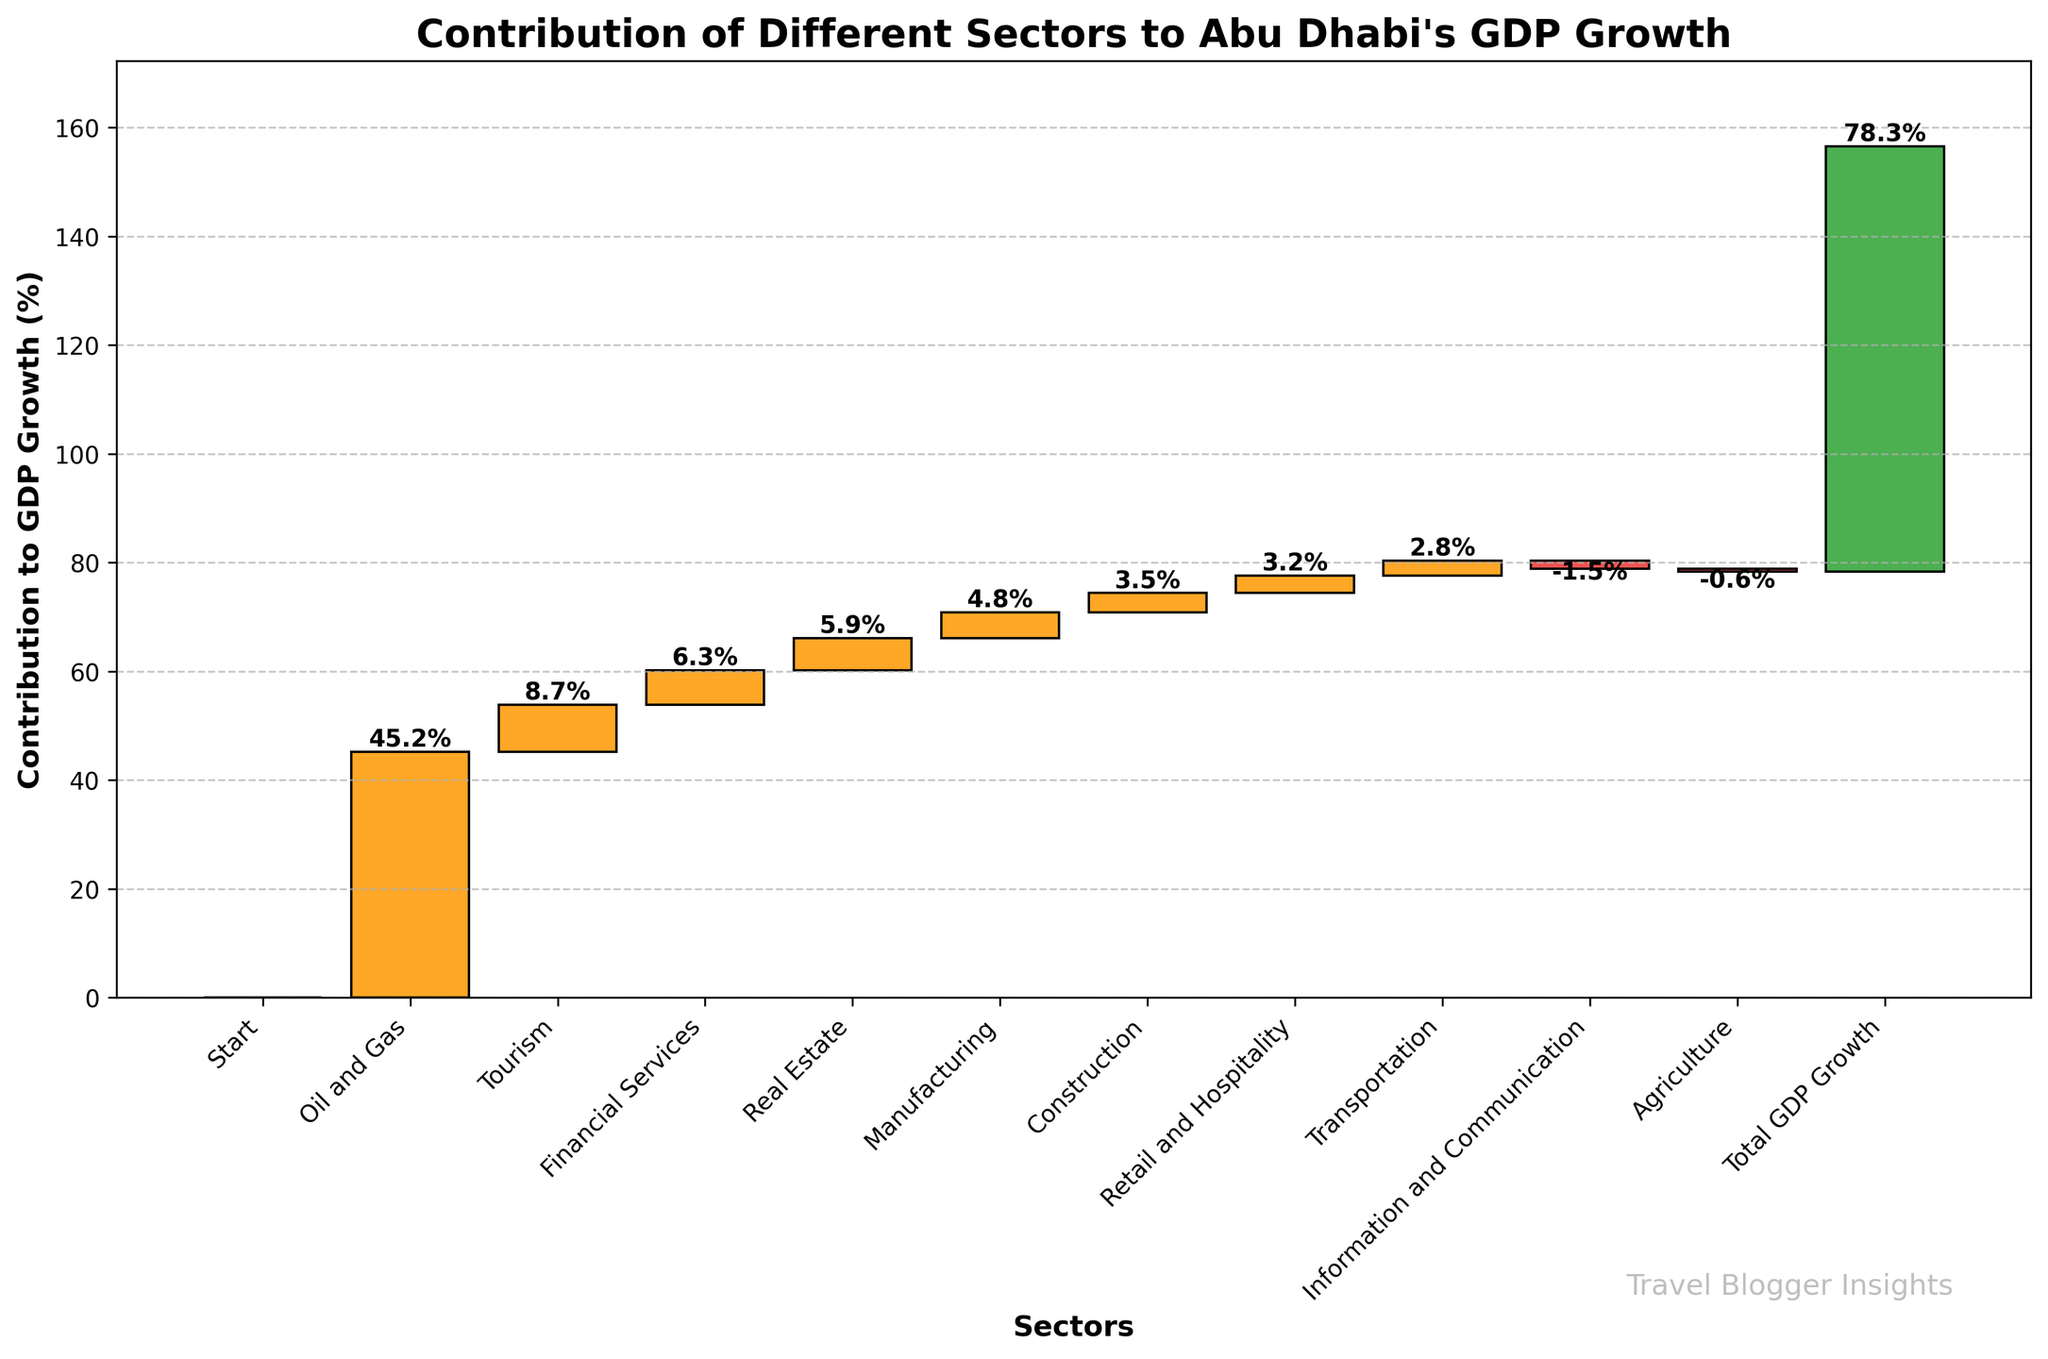What is the title of the figure? The title is the main text displayed at the top of the plot, usually indicating what the figure represents.
Answer: Contribution of Different Sectors to Abu Dhabi's GDP Growth Which sector has the highest positive contribution to GDP growth? Look for the tallest bar that is colored in orange since positive contributions are indicated by the tallest positive bars.
Answer: Oil and Gas How much does the Information and Communication sector contribute to GDP growth? Check the bar labeled as Information and Communication; it is represented by a negative bar, indicating a negative contribution.
Answer: -1.5% What is the total GDP growth according to the chart? Find the bar labeled "Total GDP Growth," which indicates the aggregate contribution of all sectors combined.
Answer: 78.3% Which sectors show a negative contribution to GDP growth? Identify the sectors with red bars as red is used for negative contributions.
Answer: Information and Communication, Agriculture What is the combined contribution of Financial Services and Real Estate sectors to GDP growth? Find the contributions of the Financial Services and Real Estate sectors, then sum them up (6.3 + 5.9).
Answer: 12.2% How many sectors contribute positively to GDP growth? Count the number of orange bars on the chart, indicating positive contributions.
Answer: 7 Which sectors contribute more than 5% to GDP growth? Identify the sectors with bars larger than 5%, marked with their respective labels.
Answer: Oil and Gas, Tourism, Financial Services, Real Estate What is the difference in contribution between the Manufacturing and Construction sectors? Find the bar heights for Manufacturing and Construction and calculate the difference (4.8 - 3.5).
Answer: 1.3% How does the contribution of the Agriculture sector compare to that of the Transportation sector? Compare the heights of the bars labeled Agriculture and Transportation; Agriculture has a negative contribution and Transportation a positive one.
Answer: Transportation contributes positively (2.8%) while Agriculture contributes negatively (-0.6%) 